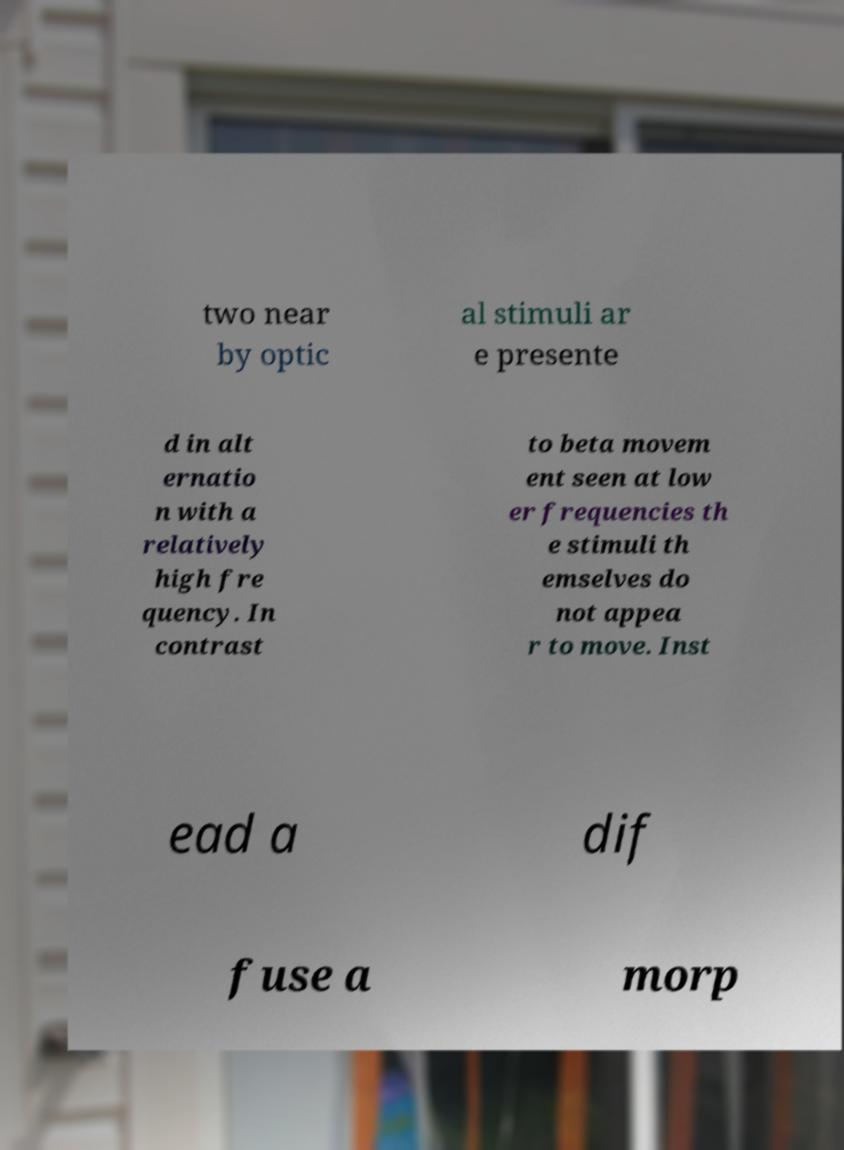What messages or text are displayed in this image? I need them in a readable, typed format. two near by optic al stimuli ar e presente d in alt ernatio n with a relatively high fre quency. In contrast to beta movem ent seen at low er frequencies th e stimuli th emselves do not appea r to move. Inst ead a dif fuse a morp 